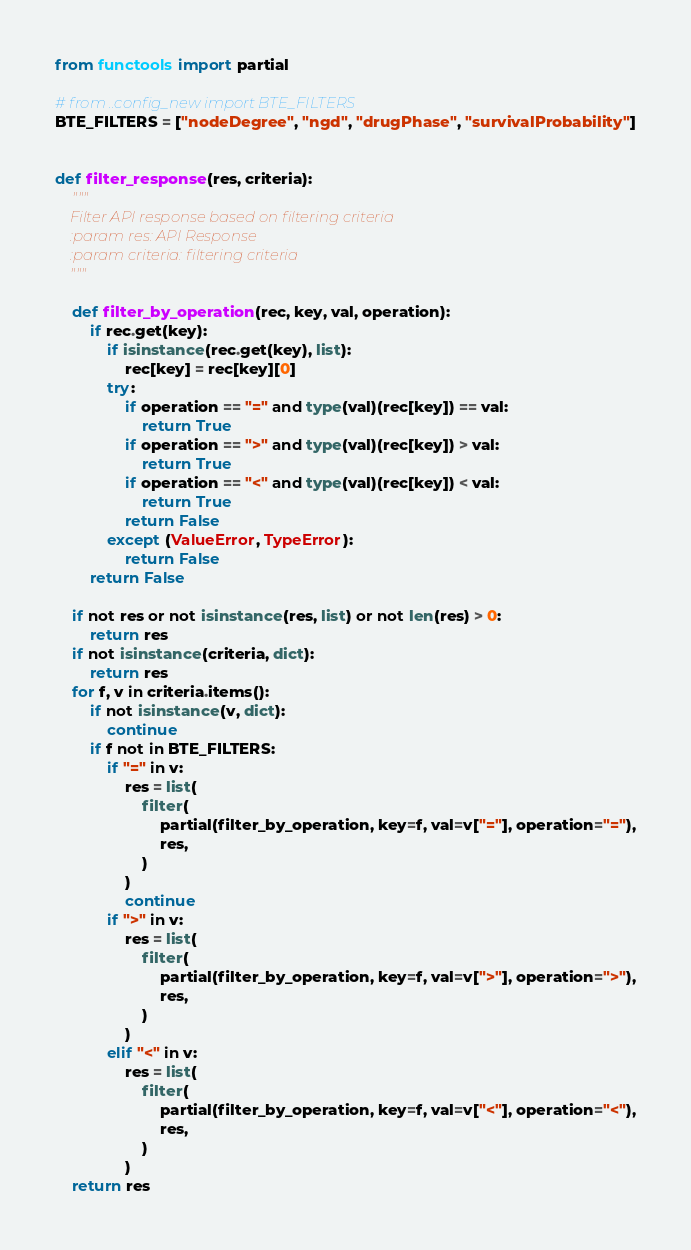<code> <loc_0><loc_0><loc_500><loc_500><_Python_>from functools import partial

# from ..config_new import BTE_FILTERS
BTE_FILTERS = ["nodeDegree", "ngd", "drugPhase", "survivalProbability"]


def filter_response(res, criteria):
    """
    Filter API response based on filtering criteria
    :param res: API Response
    :param criteria: filtering criteria
    """

    def filter_by_operation(rec, key, val, operation):
        if rec.get(key):
            if isinstance(rec.get(key), list):
                rec[key] = rec[key][0]
            try:
                if operation == "=" and type(val)(rec[key]) == val:
                    return True
                if operation == ">" and type(val)(rec[key]) > val:
                    return True
                if operation == "<" and type(val)(rec[key]) < val:
                    return True
                return False
            except (ValueError, TypeError):
                return False
        return False

    if not res or not isinstance(res, list) or not len(res) > 0:
        return res
    if not isinstance(criteria, dict):
        return res
    for f, v in criteria.items():
        if not isinstance(v, dict):
            continue
        if f not in BTE_FILTERS:
            if "=" in v:
                res = list(
                    filter(
                        partial(filter_by_operation, key=f, val=v["="], operation="="),
                        res,
                    )
                )
                continue
            if ">" in v:
                res = list(
                    filter(
                        partial(filter_by_operation, key=f, val=v[">"], operation=">"),
                        res,
                    )
                )
            elif "<" in v:
                res = list(
                    filter(
                        partial(filter_by_operation, key=f, val=v["<"], operation="<"),
                        res,
                    )
                )
    return res
</code> 